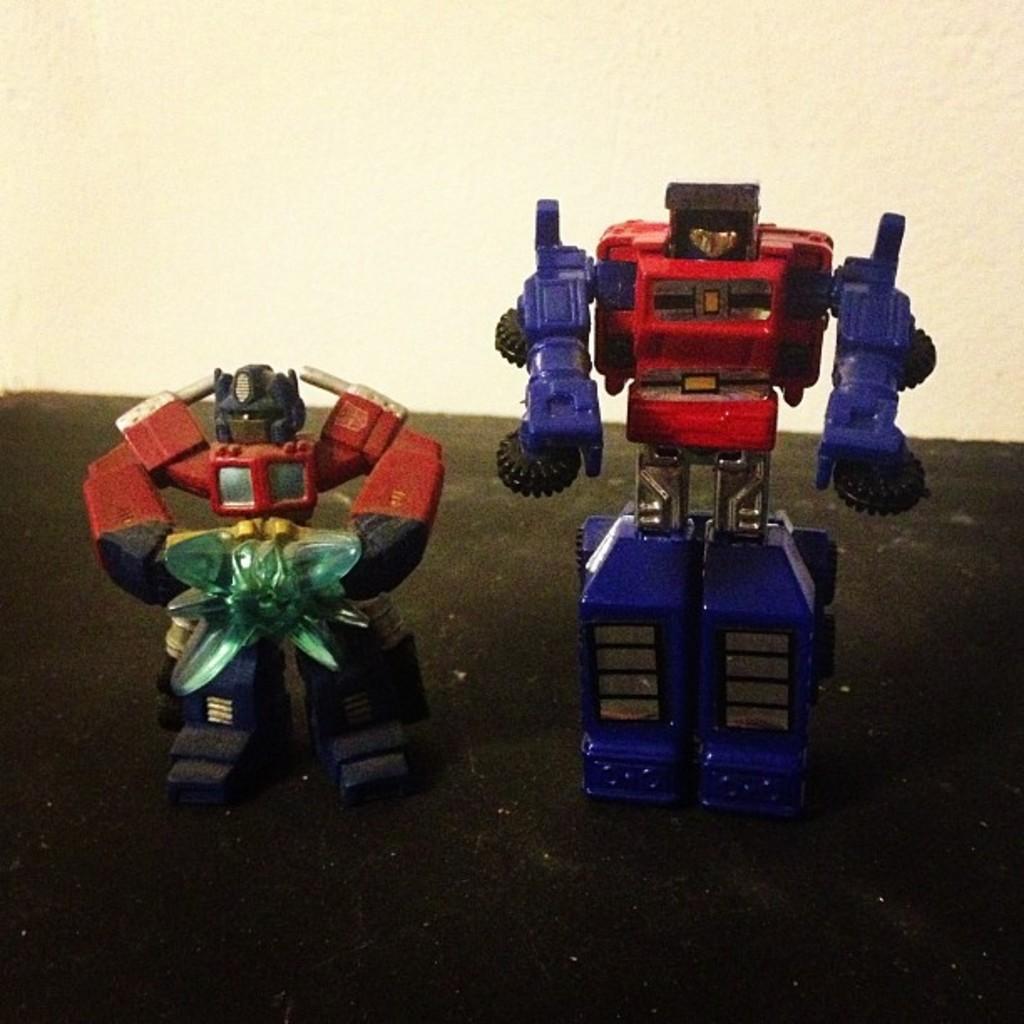Can you describe this image briefly? Here we can see two toys on a platform and this is the wall. 